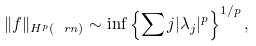Convert formula to latex. <formula><loc_0><loc_0><loc_500><loc_500>\| f \| _ { H ^ { p } ( \ r n ) } \sim \inf \left \{ \sum j | \lambda _ { j } | ^ { p } \right \} ^ { 1 / p } ,</formula> 